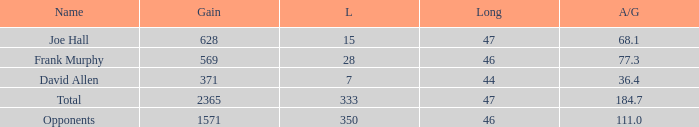How much Avg/G has a Gain smaller than 1571, and a Long smaller than 46? 1.0. 